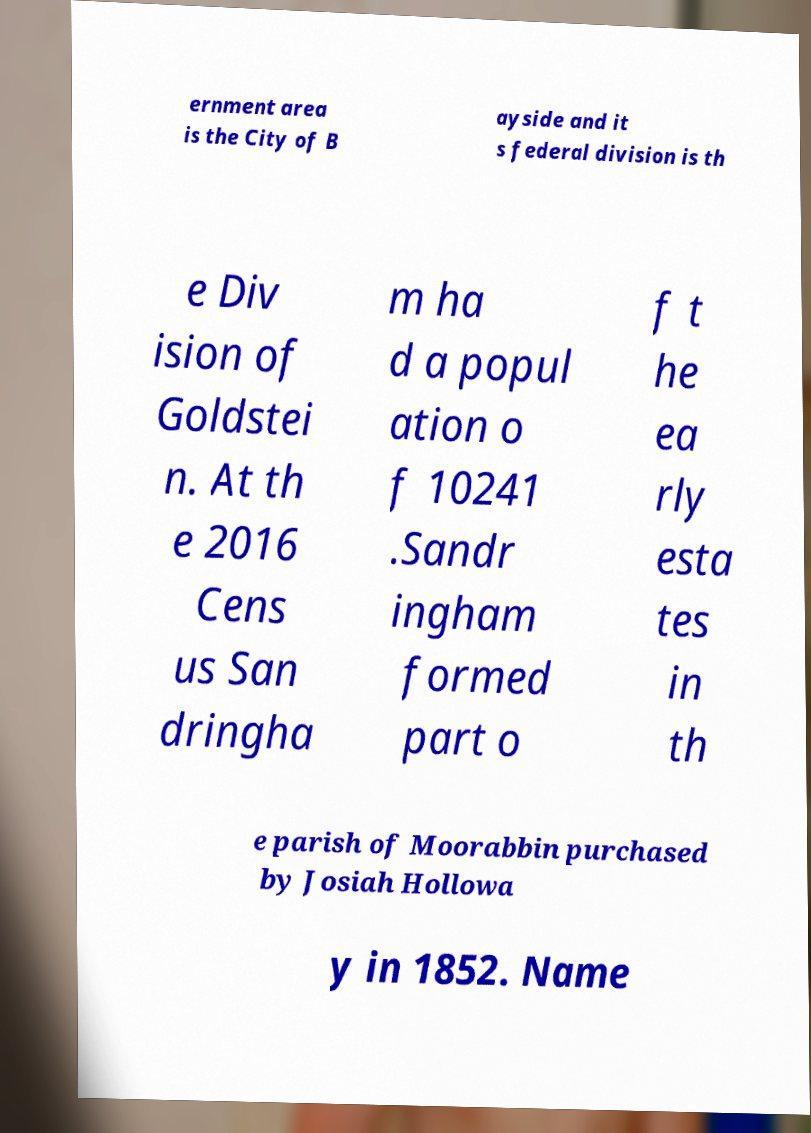Could you assist in decoding the text presented in this image and type it out clearly? ernment area is the City of B ayside and it s federal division is th e Div ision of Goldstei n. At th e 2016 Cens us San dringha m ha d a popul ation o f 10241 .Sandr ingham formed part o f t he ea rly esta tes in th e parish of Moorabbin purchased by Josiah Hollowa y in 1852. Name 